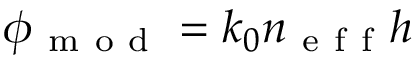<formula> <loc_0><loc_0><loc_500><loc_500>\phi _ { m o d } = k _ { 0 } n _ { e f f } h</formula> 